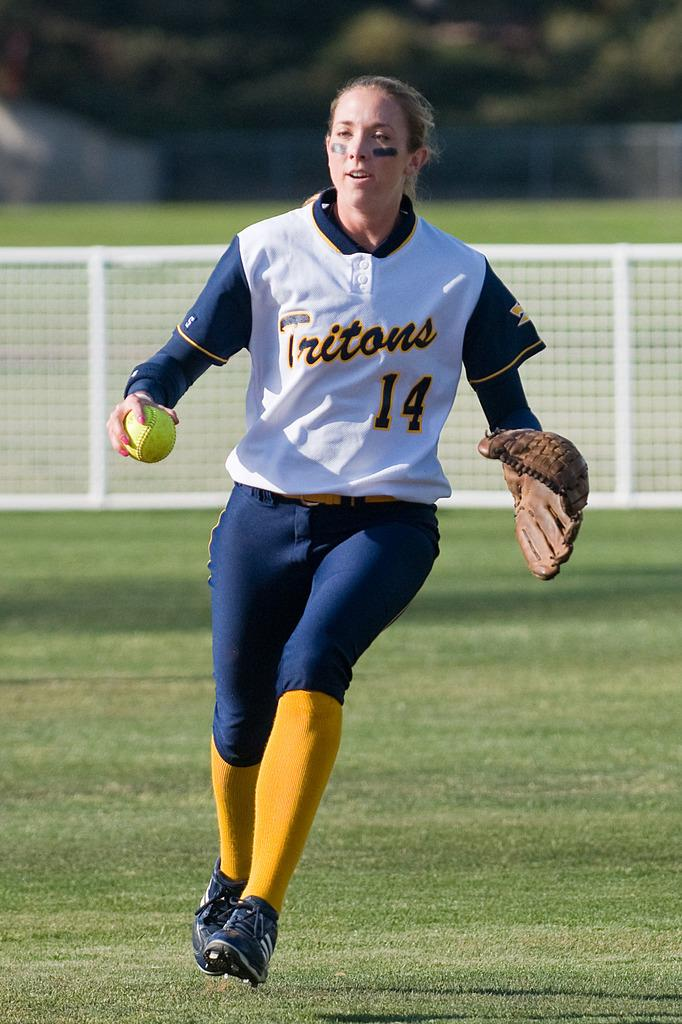Who is the main subject in the image? There is a lady in the image. What is the lady holding in the image? The lady is holding a ball. What is the lady wearing on her hands? The lady is wearing gloves. What is the lady doing in the image? The lady is running on a ground. What can be seen in the background of the image? There is fencing in the background of the image. How is the fencing depicted in the image? The fencing is blurred. What type of mint is growing near the lady in the image? There is no mint present in the image. What material is the steel fence made of in the image? There is no steel fence present in the image; it is a blurred fencing, but the material is not specified. 